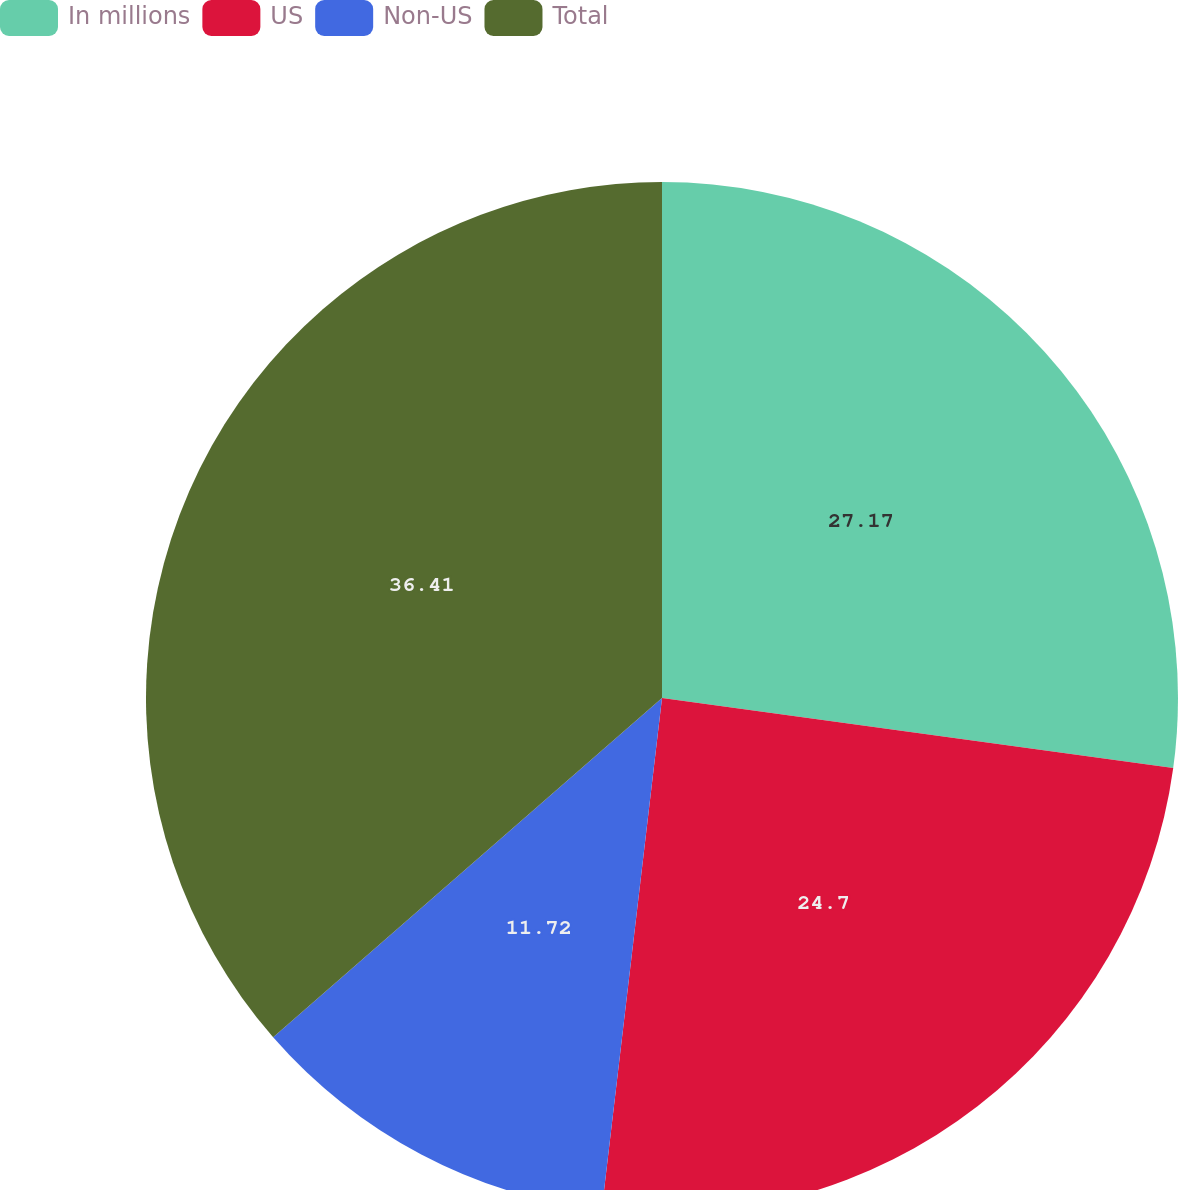<chart> <loc_0><loc_0><loc_500><loc_500><pie_chart><fcel>In millions<fcel>US<fcel>Non-US<fcel>Total<nl><fcel>27.17%<fcel>24.7%<fcel>11.72%<fcel>36.42%<nl></chart> 